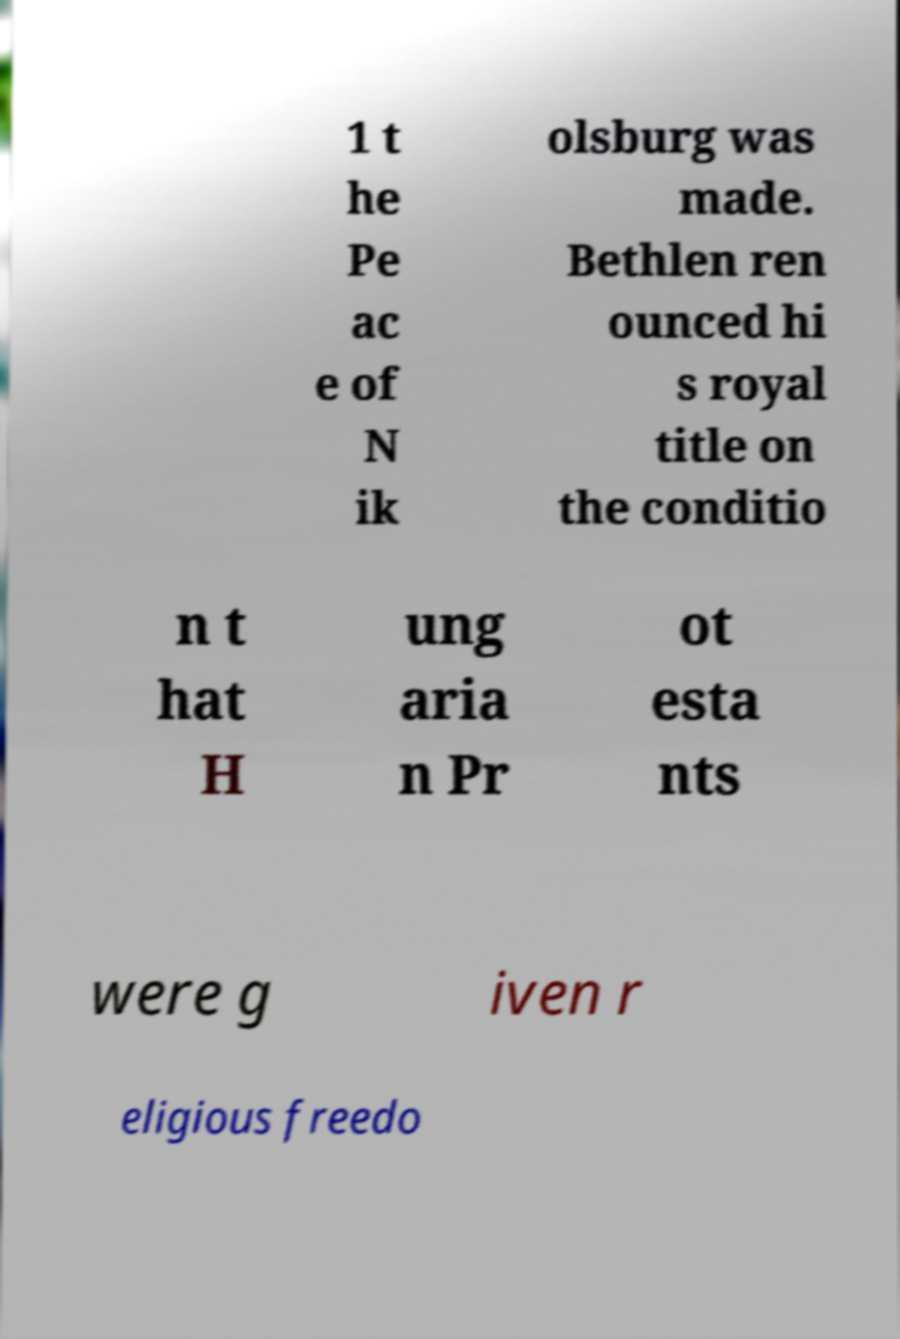Please read and relay the text visible in this image. What does it say? 1 t he Pe ac e of N ik olsburg was made. Bethlen ren ounced hi s royal title on the conditio n t hat H ung aria n Pr ot esta nts were g iven r eligious freedo 